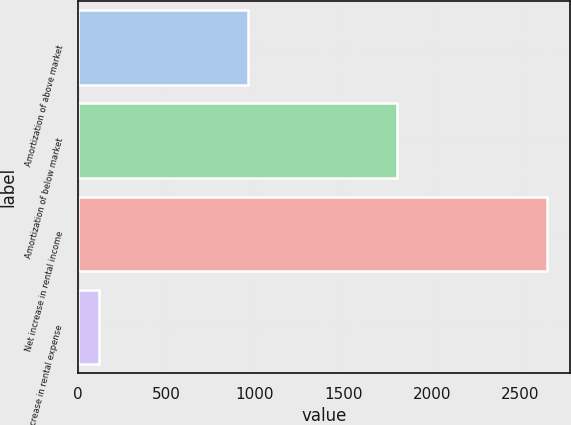Convert chart. <chart><loc_0><loc_0><loc_500><loc_500><bar_chart><fcel>Amortization of above market<fcel>Amortization of below market<fcel>Net increase in rental income<fcel>Net increase in rental expense<nl><fcel>963.1<fcel>1806.2<fcel>2649.3<fcel>120<nl></chart> 